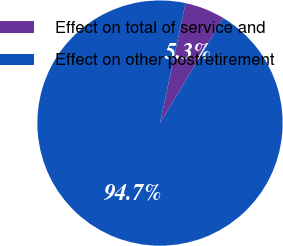Convert chart to OTSL. <chart><loc_0><loc_0><loc_500><loc_500><pie_chart><fcel>Effect on total of service and<fcel>Effect on other postretirement<nl><fcel>5.31%<fcel>94.69%<nl></chart> 